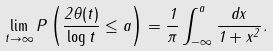Convert formula to latex. <formula><loc_0><loc_0><loc_500><loc_500>\lim _ { t \to \infty } P \left ( \frac { 2 \theta ( t ) } { \log t } \leq a \right ) = \frac { 1 } { \pi } \int _ { - \infty } ^ { a } \frac { d x } { 1 + x ^ { 2 } } .</formula> 